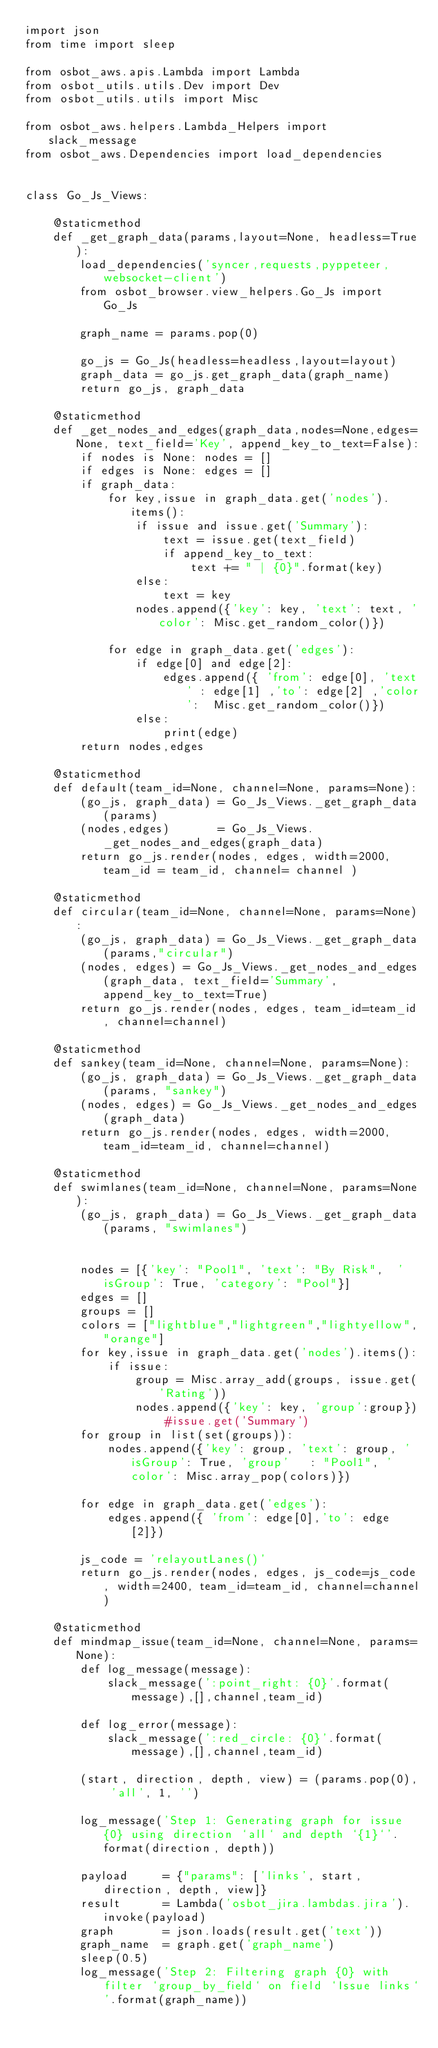<code> <loc_0><loc_0><loc_500><loc_500><_Python_>import json
from time import sleep

from osbot_aws.apis.Lambda import Lambda
from osbot_utils.utils.Dev import Dev
from osbot_utils.utils import Misc

from osbot_aws.helpers.Lambda_Helpers import slack_message
from osbot_aws.Dependencies import load_dependencies


class Go_Js_Views:

    @staticmethod
    def _get_graph_data(params,layout=None, headless=True):
        load_dependencies('syncer,requests,pyppeteer,websocket-client')
        from osbot_browser.view_helpers.Go_Js import Go_Js

        graph_name = params.pop(0)

        go_js = Go_Js(headless=headless,layout=layout)
        graph_data = go_js.get_graph_data(graph_name)
        return go_js, graph_data

    @staticmethod
    def _get_nodes_and_edges(graph_data,nodes=None,edges=None, text_field='Key', append_key_to_text=False):
        if nodes is None: nodes = []
        if edges is None: edges = []
        if graph_data:
            for key,issue in graph_data.get('nodes').items():
                if issue and issue.get('Summary'):
                    text = issue.get(text_field)
                    if append_key_to_text:
                        text += " | {0}".format(key)
                else:
                    text = key
                nodes.append({'key': key, 'text': text, 'color': Misc.get_random_color()})

            for edge in graph_data.get('edges'):
                if edge[0] and edge[2]:
                    edges.append({ 'from': edge[0], 'text' : edge[1] ,'to': edge[2] ,'color':  Misc.get_random_color()})
                else:
                    print(edge)
        return nodes,edges

    @staticmethod
    def default(team_id=None, channel=None, params=None):
        (go_js, graph_data) = Go_Js_Views._get_graph_data(params)
        (nodes,edges)       = Go_Js_Views._get_nodes_and_edges(graph_data)
        return go_js.render(nodes, edges, width=2000,team_id = team_id, channel= channel )

    @staticmethod
    def circular(team_id=None, channel=None, params=None):
        (go_js, graph_data) = Go_Js_Views._get_graph_data(params,"circular")
        (nodes, edges) = Go_Js_Views._get_nodes_and_edges(graph_data, text_field='Summary', append_key_to_text=True)
        return go_js.render(nodes, edges, team_id=team_id, channel=channel)

    @staticmethod
    def sankey(team_id=None, channel=None, params=None):
        (go_js, graph_data) = Go_Js_Views._get_graph_data(params, "sankey")
        (nodes, edges) = Go_Js_Views._get_nodes_and_edges(graph_data)
        return go_js.render(nodes, edges, width=2000, team_id=team_id, channel=channel)

    @staticmethod
    def swimlanes(team_id=None, channel=None, params=None):
        (go_js, graph_data) = Go_Js_Views._get_graph_data(params, "swimlanes")


        nodes = [{'key': "Pool1", 'text': "By Risk",  'isGroup': True, 'category': "Pool"}]
        edges = []
        groups = []
        colors = ["lightblue","lightgreen","lightyellow","orange"]
        for key,issue in graph_data.get('nodes').items():
            if issue:
                group = Misc.array_add(groups, issue.get('Rating'))
                nodes.append({'key': key, 'group':group}) #issue.get('Summary')
        for group in list(set(groups)):
            nodes.append({'key': group, 'text': group, 'isGroup': True, 'group'   : "Pool1", 'color': Misc.array_pop(colors)})

        for edge in graph_data.get('edges'):
            edges.append({ 'from': edge[0],'to': edge[2]})

        js_code = 'relayoutLanes()'
        return go_js.render(nodes, edges, js_code=js_code, width=2400, team_id=team_id, channel=channel)

    @staticmethod
    def mindmap_issue(team_id=None, channel=None, params=None):
        def log_message(message):
            slack_message(':point_right: {0}'.format(message),[],channel,team_id)

        def log_error(message):
            slack_message(':red_circle: {0}'.format(message),[],channel,team_id)

        (start, direction, depth, view) = (params.pop(0), 'all', 1, '')

        log_message('Step 1: Generating graph for issue {0} using direction `all` and depth `{1}`'.format(direction, depth))

        payload     = {"params": ['links', start, direction, depth, view]}
        result      = Lambda('osbot_jira.lambdas.jira').invoke(payload)
        graph       = json.loads(result.get('text'))
        graph_name  = graph.get('graph_name')
        sleep(0.5)
        log_message('Step 2: Filtering graph {0} with filter `group_by_field` on field `Issue links`'.format(graph_name))</code> 